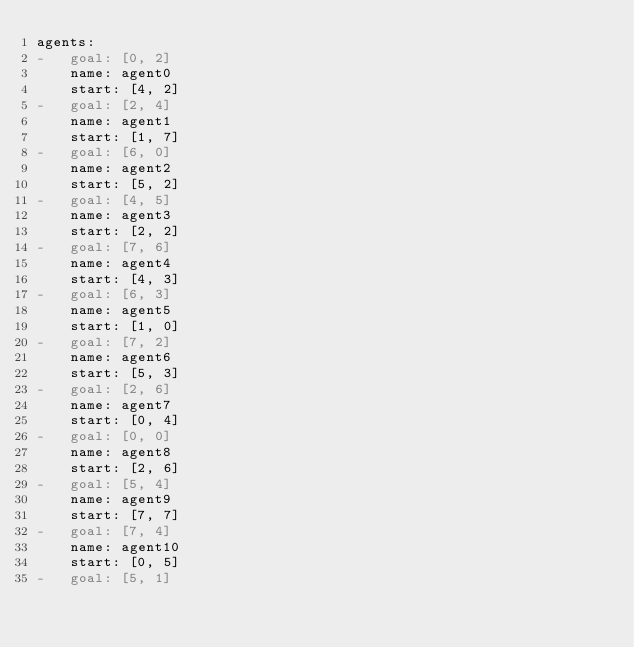<code> <loc_0><loc_0><loc_500><loc_500><_YAML_>agents:
-   goal: [0, 2]
    name: agent0
    start: [4, 2]
-   goal: [2, 4]
    name: agent1
    start: [1, 7]
-   goal: [6, 0]
    name: agent2
    start: [5, 2]
-   goal: [4, 5]
    name: agent3
    start: [2, 2]
-   goal: [7, 6]
    name: agent4
    start: [4, 3]
-   goal: [6, 3]
    name: agent5
    start: [1, 0]
-   goal: [7, 2]
    name: agent6
    start: [5, 3]
-   goal: [2, 6]
    name: agent7
    start: [0, 4]
-   goal: [0, 0]
    name: agent8
    start: [2, 6]
-   goal: [5, 4]
    name: agent9
    start: [7, 7]
-   goal: [7, 4]
    name: agent10
    start: [0, 5]
-   goal: [5, 1]</code> 